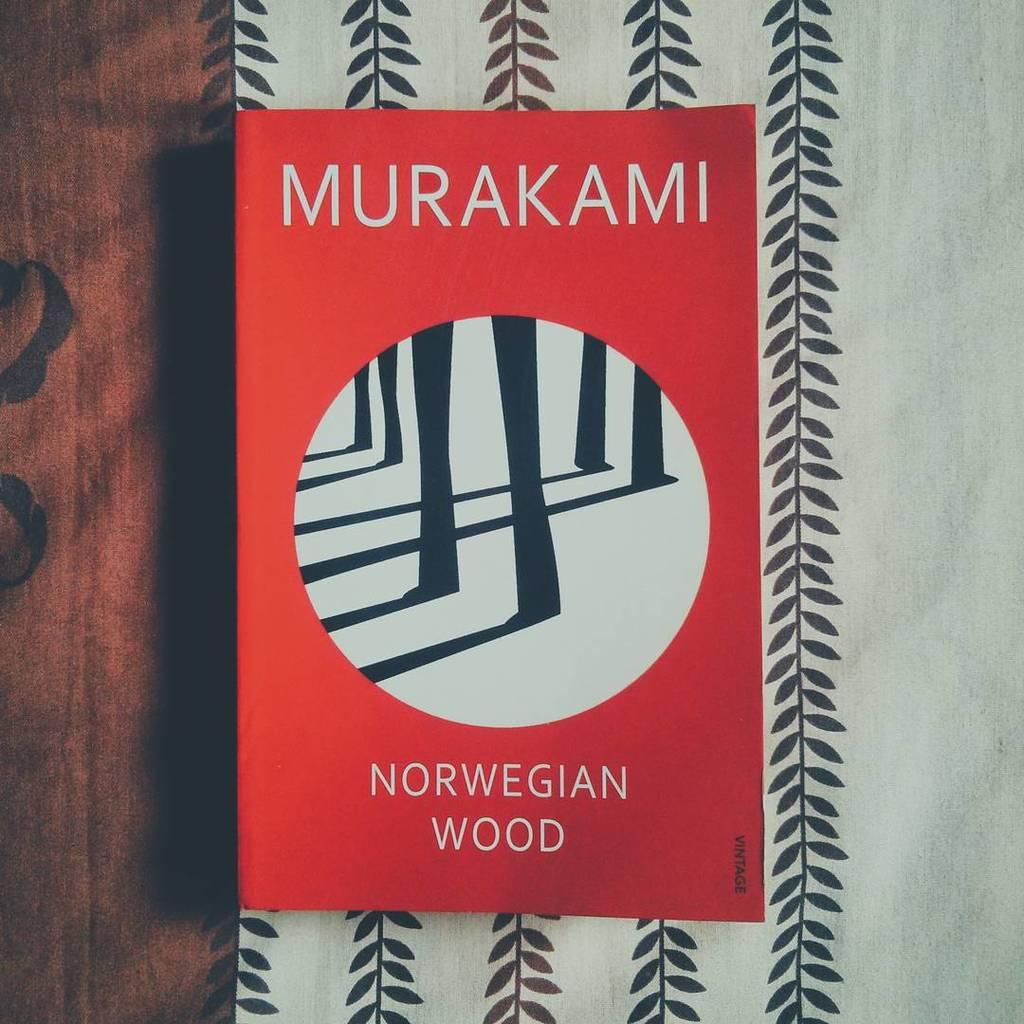<image>
Render a clear and concise summary of the photo. A red book by Murakami sits on top of some black and white fabric. 